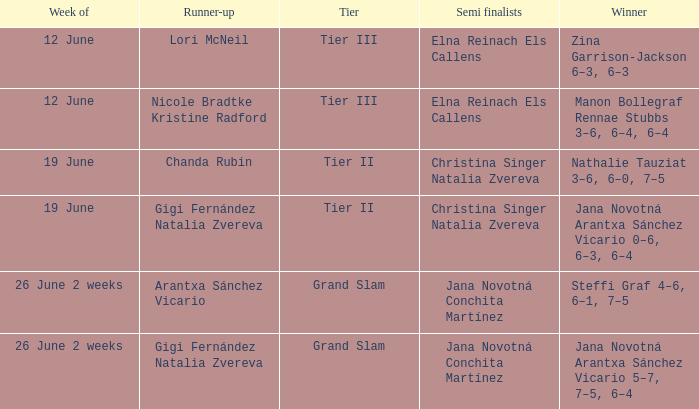When the runner-up is listed as Gigi Fernández Natalia Zvereva and the week is 26 June 2 weeks, who are the semi finalists? Jana Novotná Conchita Martínez. 